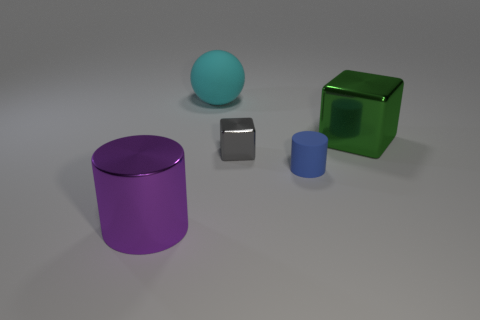What material do these objects appear to be made of? The purple and green objects seem to have a matte plastic finish, while the gray one has a metallic sheen, suggesting it might be made of metal. The spheres have a smoother surface, which could indicate a polished finish, likely plastic or possibly glass for the blue sphere. 